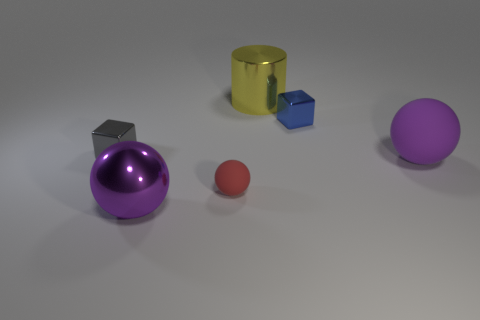Subtract all tiny matte spheres. How many spheres are left? 2 Subtract all red balls. How many balls are left? 2 Subtract all cyan cubes. How many purple balls are left? 2 Subtract 1 balls. How many balls are left? 2 Add 2 small red things. How many objects exist? 8 Subtract all blue spheres. Subtract all purple cylinders. How many spheres are left? 3 Subtract all cylinders. How many objects are left? 5 Add 1 purple balls. How many purple balls are left? 3 Add 2 small blue objects. How many small blue objects exist? 3 Subtract 0 cyan cubes. How many objects are left? 6 